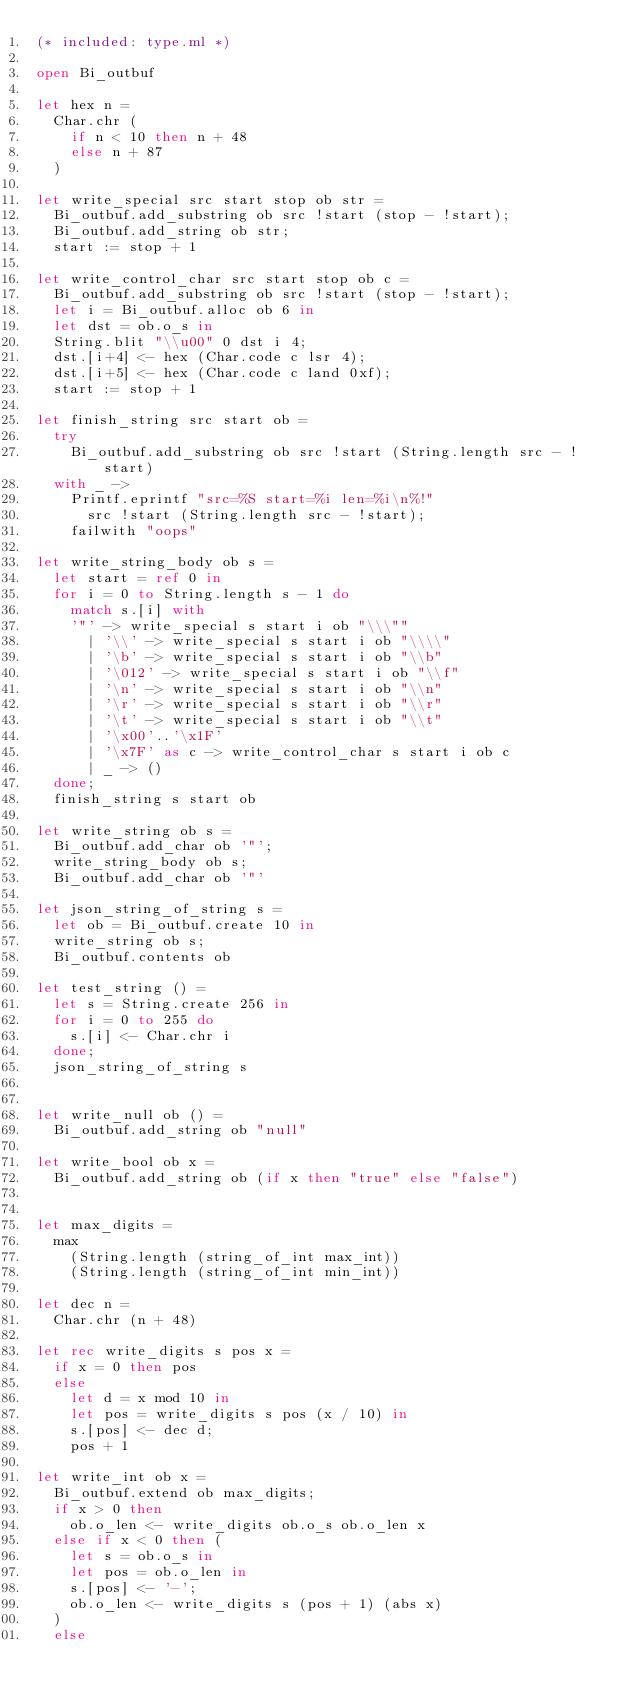Convert code to text. <code><loc_0><loc_0><loc_500><loc_500><_OCaml_>(* included: type.ml *)

open Bi_outbuf

let hex n =
  Char.chr (
    if n < 10 then n + 48
    else n + 87
  )

let write_special src start stop ob str =
  Bi_outbuf.add_substring ob src !start (stop - !start);
  Bi_outbuf.add_string ob str;
  start := stop + 1

let write_control_char src start stop ob c =
  Bi_outbuf.add_substring ob src !start (stop - !start);
  let i = Bi_outbuf.alloc ob 6 in
  let dst = ob.o_s in
  String.blit "\\u00" 0 dst i 4;
  dst.[i+4] <- hex (Char.code c lsr 4);
  dst.[i+5] <- hex (Char.code c land 0xf);
  start := stop + 1

let finish_string src start ob =
  try
    Bi_outbuf.add_substring ob src !start (String.length src - !start)
  with _ ->
    Printf.eprintf "src=%S start=%i len=%i\n%!"
      src !start (String.length src - !start);
    failwith "oops"

let write_string_body ob s =
  let start = ref 0 in
  for i = 0 to String.length s - 1 do
    match s.[i] with
	'"' -> write_special s start i ob "\\\""
      | '\\' -> write_special s start i ob "\\\\"
      | '\b' -> write_special s start i ob "\\b"
      | '\012' -> write_special s start i ob "\\f"
      | '\n' -> write_special s start i ob "\\n"
      | '\r' -> write_special s start i ob "\\r"
      | '\t' -> write_special s start i ob "\\t"
      | '\x00'..'\x1F'
      | '\x7F' as c -> write_control_char s start i ob c
      | _ -> ()
  done;
  finish_string s start ob

let write_string ob s =
  Bi_outbuf.add_char ob '"';
  write_string_body ob s;
  Bi_outbuf.add_char ob '"'

let json_string_of_string s =
  let ob = Bi_outbuf.create 10 in
  write_string ob s;
  Bi_outbuf.contents ob

let test_string () =
  let s = String.create 256 in
  for i = 0 to 255 do
    s.[i] <- Char.chr i
  done;
  json_string_of_string s


let write_null ob () =
  Bi_outbuf.add_string ob "null"

let write_bool ob x =
  Bi_outbuf.add_string ob (if x then "true" else "false")


let max_digits =
  max
    (String.length (string_of_int max_int))
    (String.length (string_of_int min_int))

let dec n =
  Char.chr (n + 48)

let rec write_digits s pos x =
  if x = 0 then pos
  else
    let d = x mod 10 in
    let pos = write_digits s pos (x / 10) in
    s.[pos] <- dec d;
    pos + 1

let write_int ob x =
  Bi_outbuf.extend ob max_digits;
  if x > 0 then
    ob.o_len <- write_digits ob.o_s ob.o_len x
  else if x < 0 then (
    let s = ob.o_s in
    let pos = ob.o_len in
    s.[pos] <- '-';
    ob.o_len <- write_digits s (pos + 1) (abs x)
  )
  else</code> 